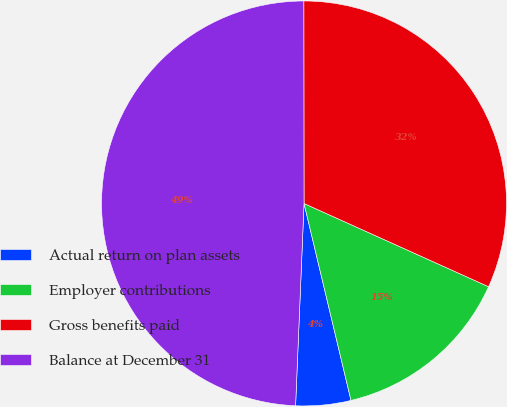Convert chart. <chart><loc_0><loc_0><loc_500><loc_500><pie_chart><fcel>Actual return on plan assets<fcel>Employer contributions<fcel>Gross benefits paid<fcel>Balance at December 31<nl><fcel>4.39%<fcel>14.53%<fcel>31.76%<fcel>49.32%<nl></chart> 